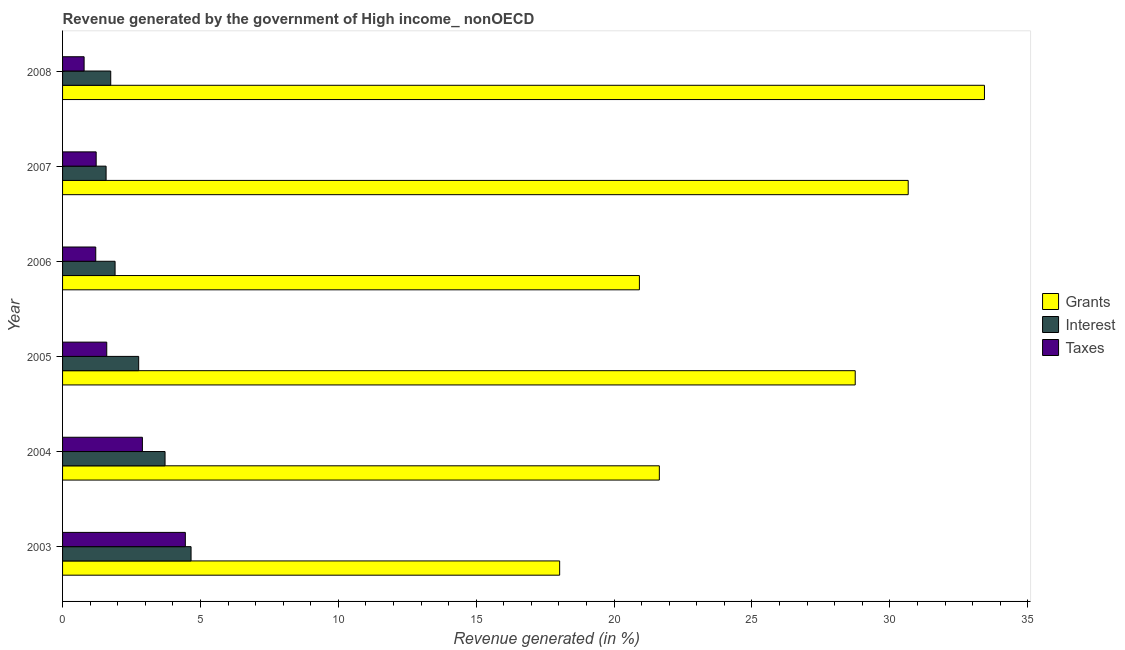How many groups of bars are there?
Your answer should be very brief. 6. Are the number of bars per tick equal to the number of legend labels?
Offer a very short reply. Yes. How many bars are there on the 3rd tick from the top?
Give a very brief answer. 3. What is the percentage of revenue generated by grants in 2007?
Offer a terse response. 30.66. Across all years, what is the maximum percentage of revenue generated by taxes?
Give a very brief answer. 4.45. Across all years, what is the minimum percentage of revenue generated by interest?
Your answer should be very brief. 1.58. In which year was the percentage of revenue generated by grants maximum?
Offer a terse response. 2008. What is the total percentage of revenue generated by taxes in the graph?
Your response must be concise. 12.15. What is the difference between the percentage of revenue generated by taxes in 2003 and that in 2006?
Ensure brevity in your answer.  3.25. What is the difference between the percentage of revenue generated by taxes in 2005 and the percentage of revenue generated by interest in 2004?
Give a very brief answer. -2.11. What is the average percentage of revenue generated by grants per year?
Your response must be concise. 25.57. In the year 2005, what is the difference between the percentage of revenue generated by grants and percentage of revenue generated by interest?
Provide a succinct answer. 25.98. What is the ratio of the percentage of revenue generated by grants in 2003 to that in 2006?
Provide a short and direct response. 0.86. Is the percentage of revenue generated by grants in 2005 less than that in 2006?
Your answer should be compact. No. Is the difference between the percentage of revenue generated by taxes in 2007 and 2008 greater than the difference between the percentage of revenue generated by interest in 2007 and 2008?
Give a very brief answer. Yes. What is the difference between the highest and the second highest percentage of revenue generated by interest?
Offer a very short reply. 0.94. What is the difference between the highest and the lowest percentage of revenue generated by interest?
Offer a terse response. 3.08. Is the sum of the percentage of revenue generated by grants in 2006 and 2008 greater than the maximum percentage of revenue generated by interest across all years?
Ensure brevity in your answer.  Yes. What does the 3rd bar from the top in 2003 represents?
Make the answer very short. Grants. What does the 2nd bar from the bottom in 2006 represents?
Ensure brevity in your answer.  Interest. Does the graph contain any zero values?
Keep it short and to the point. No. Does the graph contain grids?
Your answer should be very brief. No. What is the title of the graph?
Offer a terse response. Revenue generated by the government of High income_ nonOECD. Does "Infant(female)" appear as one of the legend labels in the graph?
Provide a short and direct response. No. What is the label or title of the X-axis?
Make the answer very short. Revenue generated (in %). What is the Revenue generated (in %) of Grants in 2003?
Your answer should be compact. 18.03. What is the Revenue generated (in %) of Interest in 2003?
Your response must be concise. 4.66. What is the Revenue generated (in %) of Taxes in 2003?
Provide a succinct answer. 4.45. What is the Revenue generated (in %) of Grants in 2004?
Provide a succinct answer. 21.64. What is the Revenue generated (in %) of Interest in 2004?
Make the answer very short. 3.72. What is the Revenue generated (in %) of Taxes in 2004?
Your answer should be very brief. 2.89. What is the Revenue generated (in %) of Grants in 2005?
Ensure brevity in your answer.  28.74. What is the Revenue generated (in %) of Interest in 2005?
Provide a short and direct response. 2.76. What is the Revenue generated (in %) in Taxes in 2005?
Keep it short and to the point. 1.6. What is the Revenue generated (in %) of Grants in 2006?
Provide a succinct answer. 20.92. What is the Revenue generated (in %) of Interest in 2006?
Your answer should be very brief. 1.9. What is the Revenue generated (in %) of Taxes in 2006?
Keep it short and to the point. 1.2. What is the Revenue generated (in %) of Grants in 2007?
Make the answer very short. 30.66. What is the Revenue generated (in %) of Interest in 2007?
Your response must be concise. 1.58. What is the Revenue generated (in %) in Taxes in 2007?
Keep it short and to the point. 1.22. What is the Revenue generated (in %) in Grants in 2008?
Your answer should be very brief. 33.43. What is the Revenue generated (in %) of Interest in 2008?
Offer a terse response. 1.75. What is the Revenue generated (in %) of Taxes in 2008?
Provide a short and direct response. 0.78. Across all years, what is the maximum Revenue generated (in %) of Grants?
Your answer should be very brief. 33.43. Across all years, what is the maximum Revenue generated (in %) of Interest?
Your response must be concise. 4.66. Across all years, what is the maximum Revenue generated (in %) in Taxes?
Keep it short and to the point. 4.45. Across all years, what is the minimum Revenue generated (in %) of Grants?
Provide a short and direct response. 18.03. Across all years, what is the minimum Revenue generated (in %) in Interest?
Your answer should be very brief. 1.58. Across all years, what is the minimum Revenue generated (in %) of Taxes?
Give a very brief answer. 0.78. What is the total Revenue generated (in %) of Grants in the graph?
Your answer should be compact. 153.42. What is the total Revenue generated (in %) of Interest in the graph?
Your answer should be compact. 16.36. What is the total Revenue generated (in %) of Taxes in the graph?
Provide a succinct answer. 12.15. What is the difference between the Revenue generated (in %) of Grants in 2003 and that in 2004?
Your answer should be compact. -3.61. What is the difference between the Revenue generated (in %) in Interest in 2003 and that in 2004?
Keep it short and to the point. 0.94. What is the difference between the Revenue generated (in %) of Taxes in 2003 and that in 2004?
Offer a terse response. 1.56. What is the difference between the Revenue generated (in %) in Grants in 2003 and that in 2005?
Offer a terse response. -10.72. What is the difference between the Revenue generated (in %) in Interest in 2003 and that in 2005?
Provide a succinct answer. 1.9. What is the difference between the Revenue generated (in %) in Taxes in 2003 and that in 2005?
Your answer should be compact. 2.85. What is the difference between the Revenue generated (in %) in Grants in 2003 and that in 2006?
Offer a terse response. -2.89. What is the difference between the Revenue generated (in %) of Interest in 2003 and that in 2006?
Your answer should be compact. 2.76. What is the difference between the Revenue generated (in %) in Taxes in 2003 and that in 2006?
Keep it short and to the point. 3.25. What is the difference between the Revenue generated (in %) of Grants in 2003 and that in 2007?
Provide a succinct answer. -12.64. What is the difference between the Revenue generated (in %) of Interest in 2003 and that in 2007?
Keep it short and to the point. 3.08. What is the difference between the Revenue generated (in %) of Taxes in 2003 and that in 2007?
Your answer should be compact. 3.23. What is the difference between the Revenue generated (in %) in Grants in 2003 and that in 2008?
Provide a succinct answer. -15.4. What is the difference between the Revenue generated (in %) in Interest in 2003 and that in 2008?
Make the answer very short. 2.91. What is the difference between the Revenue generated (in %) in Taxes in 2003 and that in 2008?
Keep it short and to the point. 3.67. What is the difference between the Revenue generated (in %) of Grants in 2004 and that in 2005?
Your answer should be compact. -7.1. What is the difference between the Revenue generated (in %) of Interest in 2004 and that in 2005?
Offer a terse response. 0.96. What is the difference between the Revenue generated (in %) in Taxes in 2004 and that in 2005?
Keep it short and to the point. 1.29. What is the difference between the Revenue generated (in %) of Grants in 2004 and that in 2006?
Your response must be concise. 0.72. What is the difference between the Revenue generated (in %) of Interest in 2004 and that in 2006?
Your response must be concise. 1.81. What is the difference between the Revenue generated (in %) in Taxes in 2004 and that in 2006?
Your response must be concise. 1.69. What is the difference between the Revenue generated (in %) in Grants in 2004 and that in 2007?
Give a very brief answer. -9.02. What is the difference between the Revenue generated (in %) of Interest in 2004 and that in 2007?
Offer a terse response. 2.14. What is the difference between the Revenue generated (in %) of Taxes in 2004 and that in 2007?
Offer a very short reply. 1.68. What is the difference between the Revenue generated (in %) in Grants in 2004 and that in 2008?
Offer a terse response. -11.79. What is the difference between the Revenue generated (in %) in Interest in 2004 and that in 2008?
Keep it short and to the point. 1.97. What is the difference between the Revenue generated (in %) in Taxes in 2004 and that in 2008?
Provide a succinct answer. 2.11. What is the difference between the Revenue generated (in %) in Grants in 2005 and that in 2006?
Provide a succinct answer. 7.83. What is the difference between the Revenue generated (in %) in Interest in 2005 and that in 2006?
Provide a succinct answer. 0.86. What is the difference between the Revenue generated (in %) in Taxes in 2005 and that in 2006?
Your answer should be compact. 0.4. What is the difference between the Revenue generated (in %) of Grants in 2005 and that in 2007?
Provide a short and direct response. -1.92. What is the difference between the Revenue generated (in %) in Interest in 2005 and that in 2007?
Offer a terse response. 1.18. What is the difference between the Revenue generated (in %) of Taxes in 2005 and that in 2007?
Ensure brevity in your answer.  0.38. What is the difference between the Revenue generated (in %) of Grants in 2005 and that in 2008?
Your answer should be very brief. -4.69. What is the difference between the Revenue generated (in %) in Interest in 2005 and that in 2008?
Provide a succinct answer. 1.01. What is the difference between the Revenue generated (in %) in Taxes in 2005 and that in 2008?
Offer a very short reply. 0.82. What is the difference between the Revenue generated (in %) of Grants in 2006 and that in 2007?
Ensure brevity in your answer.  -9.75. What is the difference between the Revenue generated (in %) of Interest in 2006 and that in 2007?
Give a very brief answer. 0.33. What is the difference between the Revenue generated (in %) in Taxes in 2006 and that in 2007?
Provide a succinct answer. -0.02. What is the difference between the Revenue generated (in %) of Grants in 2006 and that in 2008?
Provide a short and direct response. -12.51. What is the difference between the Revenue generated (in %) in Interest in 2006 and that in 2008?
Your answer should be compact. 0.16. What is the difference between the Revenue generated (in %) in Taxes in 2006 and that in 2008?
Keep it short and to the point. 0.42. What is the difference between the Revenue generated (in %) of Grants in 2007 and that in 2008?
Provide a short and direct response. -2.77. What is the difference between the Revenue generated (in %) of Interest in 2007 and that in 2008?
Give a very brief answer. -0.17. What is the difference between the Revenue generated (in %) of Taxes in 2007 and that in 2008?
Keep it short and to the point. 0.44. What is the difference between the Revenue generated (in %) in Grants in 2003 and the Revenue generated (in %) in Interest in 2004?
Offer a terse response. 14.31. What is the difference between the Revenue generated (in %) of Grants in 2003 and the Revenue generated (in %) of Taxes in 2004?
Ensure brevity in your answer.  15.13. What is the difference between the Revenue generated (in %) in Interest in 2003 and the Revenue generated (in %) in Taxes in 2004?
Provide a short and direct response. 1.76. What is the difference between the Revenue generated (in %) in Grants in 2003 and the Revenue generated (in %) in Interest in 2005?
Ensure brevity in your answer.  15.27. What is the difference between the Revenue generated (in %) of Grants in 2003 and the Revenue generated (in %) of Taxes in 2005?
Your answer should be compact. 16.42. What is the difference between the Revenue generated (in %) of Interest in 2003 and the Revenue generated (in %) of Taxes in 2005?
Offer a very short reply. 3.06. What is the difference between the Revenue generated (in %) of Grants in 2003 and the Revenue generated (in %) of Interest in 2006?
Keep it short and to the point. 16.12. What is the difference between the Revenue generated (in %) in Grants in 2003 and the Revenue generated (in %) in Taxes in 2006?
Offer a very short reply. 16.82. What is the difference between the Revenue generated (in %) in Interest in 2003 and the Revenue generated (in %) in Taxes in 2006?
Offer a terse response. 3.46. What is the difference between the Revenue generated (in %) of Grants in 2003 and the Revenue generated (in %) of Interest in 2007?
Your response must be concise. 16.45. What is the difference between the Revenue generated (in %) of Grants in 2003 and the Revenue generated (in %) of Taxes in 2007?
Make the answer very short. 16.81. What is the difference between the Revenue generated (in %) in Interest in 2003 and the Revenue generated (in %) in Taxes in 2007?
Keep it short and to the point. 3.44. What is the difference between the Revenue generated (in %) of Grants in 2003 and the Revenue generated (in %) of Interest in 2008?
Give a very brief answer. 16.28. What is the difference between the Revenue generated (in %) of Grants in 2003 and the Revenue generated (in %) of Taxes in 2008?
Your response must be concise. 17.24. What is the difference between the Revenue generated (in %) of Interest in 2003 and the Revenue generated (in %) of Taxes in 2008?
Your answer should be very brief. 3.88. What is the difference between the Revenue generated (in %) in Grants in 2004 and the Revenue generated (in %) in Interest in 2005?
Offer a terse response. 18.88. What is the difference between the Revenue generated (in %) in Grants in 2004 and the Revenue generated (in %) in Taxes in 2005?
Give a very brief answer. 20.04. What is the difference between the Revenue generated (in %) of Interest in 2004 and the Revenue generated (in %) of Taxes in 2005?
Keep it short and to the point. 2.11. What is the difference between the Revenue generated (in %) of Grants in 2004 and the Revenue generated (in %) of Interest in 2006?
Your answer should be very brief. 19.74. What is the difference between the Revenue generated (in %) of Grants in 2004 and the Revenue generated (in %) of Taxes in 2006?
Your answer should be compact. 20.44. What is the difference between the Revenue generated (in %) of Interest in 2004 and the Revenue generated (in %) of Taxes in 2006?
Your response must be concise. 2.51. What is the difference between the Revenue generated (in %) of Grants in 2004 and the Revenue generated (in %) of Interest in 2007?
Your answer should be compact. 20.06. What is the difference between the Revenue generated (in %) of Grants in 2004 and the Revenue generated (in %) of Taxes in 2007?
Offer a terse response. 20.42. What is the difference between the Revenue generated (in %) in Interest in 2004 and the Revenue generated (in %) in Taxes in 2007?
Keep it short and to the point. 2.5. What is the difference between the Revenue generated (in %) in Grants in 2004 and the Revenue generated (in %) in Interest in 2008?
Offer a terse response. 19.89. What is the difference between the Revenue generated (in %) in Grants in 2004 and the Revenue generated (in %) in Taxes in 2008?
Your answer should be very brief. 20.86. What is the difference between the Revenue generated (in %) in Interest in 2004 and the Revenue generated (in %) in Taxes in 2008?
Give a very brief answer. 2.93. What is the difference between the Revenue generated (in %) in Grants in 2005 and the Revenue generated (in %) in Interest in 2006?
Offer a very short reply. 26.84. What is the difference between the Revenue generated (in %) in Grants in 2005 and the Revenue generated (in %) in Taxes in 2006?
Your answer should be compact. 27.54. What is the difference between the Revenue generated (in %) in Interest in 2005 and the Revenue generated (in %) in Taxes in 2006?
Your response must be concise. 1.56. What is the difference between the Revenue generated (in %) in Grants in 2005 and the Revenue generated (in %) in Interest in 2007?
Your answer should be very brief. 27.17. What is the difference between the Revenue generated (in %) in Grants in 2005 and the Revenue generated (in %) in Taxes in 2007?
Give a very brief answer. 27.52. What is the difference between the Revenue generated (in %) of Interest in 2005 and the Revenue generated (in %) of Taxes in 2007?
Make the answer very short. 1.54. What is the difference between the Revenue generated (in %) of Grants in 2005 and the Revenue generated (in %) of Interest in 2008?
Provide a succinct answer. 27. What is the difference between the Revenue generated (in %) in Grants in 2005 and the Revenue generated (in %) in Taxes in 2008?
Offer a terse response. 27.96. What is the difference between the Revenue generated (in %) in Interest in 2005 and the Revenue generated (in %) in Taxes in 2008?
Your answer should be very brief. 1.98. What is the difference between the Revenue generated (in %) of Grants in 2006 and the Revenue generated (in %) of Interest in 2007?
Offer a very short reply. 19.34. What is the difference between the Revenue generated (in %) in Grants in 2006 and the Revenue generated (in %) in Taxes in 2007?
Your answer should be very brief. 19.7. What is the difference between the Revenue generated (in %) of Interest in 2006 and the Revenue generated (in %) of Taxes in 2007?
Your response must be concise. 0.69. What is the difference between the Revenue generated (in %) in Grants in 2006 and the Revenue generated (in %) in Interest in 2008?
Your answer should be compact. 19.17. What is the difference between the Revenue generated (in %) in Grants in 2006 and the Revenue generated (in %) in Taxes in 2008?
Your response must be concise. 20.14. What is the difference between the Revenue generated (in %) in Interest in 2006 and the Revenue generated (in %) in Taxes in 2008?
Provide a succinct answer. 1.12. What is the difference between the Revenue generated (in %) in Grants in 2007 and the Revenue generated (in %) in Interest in 2008?
Your answer should be compact. 28.92. What is the difference between the Revenue generated (in %) in Grants in 2007 and the Revenue generated (in %) in Taxes in 2008?
Your answer should be very brief. 29.88. What is the difference between the Revenue generated (in %) in Interest in 2007 and the Revenue generated (in %) in Taxes in 2008?
Your response must be concise. 0.8. What is the average Revenue generated (in %) of Grants per year?
Ensure brevity in your answer.  25.57. What is the average Revenue generated (in %) in Interest per year?
Keep it short and to the point. 2.73. What is the average Revenue generated (in %) in Taxes per year?
Your response must be concise. 2.03. In the year 2003, what is the difference between the Revenue generated (in %) in Grants and Revenue generated (in %) in Interest?
Provide a succinct answer. 13.37. In the year 2003, what is the difference between the Revenue generated (in %) of Grants and Revenue generated (in %) of Taxes?
Ensure brevity in your answer.  13.57. In the year 2003, what is the difference between the Revenue generated (in %) in Interest and Revenue generated (in %) in Taxes?
Ensure brevity in your answer.  0.21. In the year 2004, what is the difference between the Revenue generated (in %) in Grants and Revenue generated (in %) in Interest?
Provide a succinct answer. 17.92. In the year 2004, what is the difference between the Revenue generated (in %) in Grants and Revenue generated (in %) in Taxes?
Your answer should be very brief. 18.75. In the year 2004, what is the difference between the Revenue generated (in %) of Interest and Revenue generated (in %) of Taxes?
Keep it short and to the point. 0.82. In the year 2005, what is the difference between the Revenue generated (in %) of Grants and Revenue generated (in %) of Interest?
Keep it short and to the point. 25.98. In the year 2005, what is the difference between the Revenue generated (in %) in Grants and Revenue generated (in %) in Taxes?
Make the answer very short. 27.14. In the year 2005, what is the difference between the Revenue generated (in %) of Interest and Revenue generated (in %) of Taxes?
Offer a terse response. 1.16. In the year 2006, what is the difference between the Revenue generated (in %) of Grants and Revenue generated (in %) of Interest?
Your response must be concise. 19.01. In the year 2006, what is the difference between the Revenue generated (in %) in Grants and Revenue generated (in %) in Taxes?
Give a very brief answer. 19.71. In the year 2006, what is the difference between the Revenue generated (in %) of Interest and Revenue generated (in %) of Taxes?
Your answer should be compact. 0.7. In the year 2007, what is the difference between the Revenue generated (in %) in Grants and Revenue generated (in %) in Interest?
Offer a very short reply. 29.09. In the year 2007, what is the difference between the Revenue generated (in %) in Grants and Revenue generated (in %) in Taxes?
Your answer should be very brief. 29.45. In the year 2007, what is the difference between the Revenue generated (in %) of Interest and Revenue generated (in %) of Taxes?
Your answer should be very brief. 0.36. In the year 2008, what is the difference between the Revenue generated (in %) in Grants and Revenue generated (in %) in Interest?
Keep it short and to the point. 31.68. In the year 2008, what is the difference between the Revenue generated (in %) of Grants and Revenue generated (in %) of Taxes?
Your answer should be very brief. 32.65. In the year 2008, what is the difference between the Revenue generated (in %) of Interest and Revenue generated (in %) of Taxes?
Make the answer very short. 0.97. What is the ratio of the Revenue generated (in %) in Grants in 2003 to that in 2004?
Give a very brief answer. 0.83. What is the ratio of the Revenue generated (in %) in Interest in 2003 to that in 2004?
Make the answer very short. 1.25. What is the ratio of the Revenue generated (in %) of Taxes in 2003 to that in 2004?
Your answer should be compact. 1.54. What is the ratio of the Revenue generated (in %) in Grants in 2003 to that in 2005?
Your response must be concise. 0.63. What is the ratio of the Revenue generated (in %) of Interest in 2003 to that in 2005?
Your answer should be compact. 1.69. What is the ratio of the Revenue generated (in %) of Taxes in 2003 to that in 2005?
Your answer should be compact. 2.78. What is the ratio of the Revenue generated (in %) in Grants in 2003 to that in 2006?
Ensure brevity in your answer.  0.86. What is the ratio of the Revenue generated (in %) of Interest in 2003 to that in 2006?
Offer a terse response. 2.45. What is the ratio of the Revenue generated (in %) of Taxes in 2003 to that in 2006?
Keep it short and to the point. 3.7. What is the ratio of the Revenue generated (in %) in Grants in 2003 to that in 2007?
Offer a very short reply. 0.59. What is the ratio of the Revenue generated (in %) in Interest in 2003 to that in 2007?
Provide a short and direct response. 2.95. What is the ratio of the Revenue generated (in %) of Taxes in 2003 to that in 2007?
Your answer should be very brief. 3.65. What is the ratio of the Revenue generated (in %) of Grants in 2003 to that in 2008?
Give a very brief answer. 0.54. What is the ratio of the Revenue generated (in %) in Interest in 2003 to that in 2008?
Make the answer very short. 2.67. What is the ratio of the Revenue generated (in %) of Taxes in 2003 to that in 2008?
Keep it short and to the point. 5.7. What is the ratio of the Revenue generated (in %) in Grants in 2004 to that in 2005?
Offer a very short reply. 0.75. What is the ratio of the Revenue generated (in %) in Interest in 2004 to that in 2005?
Your response must be concise. 1.35. What is the ratio of the Revenue generated (in %) of Taxes in 2004 to that in 2005?
Your response must be concise. 1.81. What is the ratio of the Revenue generated (in %) in Grants in 2004 to that in 2006?
Offer a terse response. 1.03. What is the ratio of the Revenue generated (in %) in Interest in 2004 to that in 2006?
Provide a short and direct response. 1.95. What is the ratio of the Revenue generated (in %) in Taxes in 2004 to that in 2006?
Make the answer very short. 2.41. What is the ratio of the Revenue generated (in %) of Grants in 2004 to that in 2007?
Offer a terse response. 0.71. What is the ratio of the Revenue generated (in %) in Interest in 2004 to that in 2007?
Ensure brevity in your answer.  2.35. What is the ratio of the Revenue generated (in %) of Taxes in 2004 to that in 2007?
Your answer should be compact. 2.38. What is the ratio of the Revenue generated (in %) in Grants in 2004 to that in 2008?
Make the answer very short. 0.65. What is the ratio of the Revenue generated (in %) in Interest in 2004 to that in 2008?
Provide a short and direct response. 2.13. What is the ratio of the Revenue generated (in %) in Taxes in 2004 to that in 2008?
Offer a very short reply. 3.7. What is the ratio of the Revenue generated (in %) in Grants in 2005 to that in 2006?
Offer a terse response. 1.37. What is the ratio of the Revenue generated (in %) of Interest in 2005 to that in 2006?
Your answer should be very brief. 1.45. What is the ratio of the Revenue generated (in %) of Taxes in 2005 to that in 2006?
Keep it short and to the point. 1.33. What is the ratio of the Revenue generated (in %) in Grants in 2005 to that in 2007?
Keep it short and to the point. 0.94. What is the ratio of the Revenue generated (in %) of Interest in 2005 to that in 2007?
Provide a succinct answer. 1.75. What is the ratio of the Revenue generated (in %) in Taxes in 2005 to that in 2007?
Ensure brevity in your answer.  1.31. What is the ratio of the Revenue generated (in %) in Grants in 2005 to that in 2008?
Give a very brief answer. 0.86. What is the ratio of the Revenue generated (in %) in Interest in 2005 to that in 2008?
Make the answer very short. 1.58. What is the ratio of the Revenue generated (in %) of Taxes in 2005 to that in 2008?
Your answer should be very brief. 2.05. What is the ratio of the Revenue generated (in %) of Grants in 2006 to that in 2007?
Your answer should be very brief. 0.68. What is the ratio of the Revenue generated (in %) in Interest in 2006 to that in 2007?
Provide a short and direct response. 1.21. What is the ratio of the Revenue generated (in %) in Taxes in 2006 to that in 2007?
Your answer should be very brief. 0.99. What is the ratio of the Revenue generated (in %) in Grants in 2006 to that in 2008?
Provide a succinct answer. 0.63. What is the ratio of the Revenue generated (in %) in Interest in 2006 to that in 2008?
Provide a short and direct response. 1.09. What is the ratio of the Revenue generated (in %) of Taxes in 2006 to that in 2008?
Provide a succinct answer. 1.54. What is the ratio of the Revenue generated (in %) of Grants in 2007 to that in 2008?
Your answer should be very brief. 0.92. What is the ratio of the Revenue generated (in %) in Interest in 2007 to that in 2008?
Make the answer very short. 0.9. What is the ratio of the Revenue generated (in %) in Taxes in 2007 to that in 2008?
Keep it short and to the point. 1.56. What is the difference between the highest and the second highest Revenue generated (in %) in Grants?
Make the answer very short. 2.77. What is the difference between the highest and the second highest Revenue generated (in %) in Interest?
Offer a terse response. 0.94. What is the difference between the highest and the second highest Revenue generated (in %) in Taxes?
Ensure brevity in your answer.  1.56. What is the difference between the highest and the lowest Revenue generated (in %) in Grants?
Your response must be concise. 15.4. What is the difference between the highest and the lowest Revenue generated (in %) of Interest?
Keep it short and to the point. 3.08. What is the difference between the highest and the lowest Revenue generated (in %) in Taxes?
Keep it short and to the point. 3.67. 